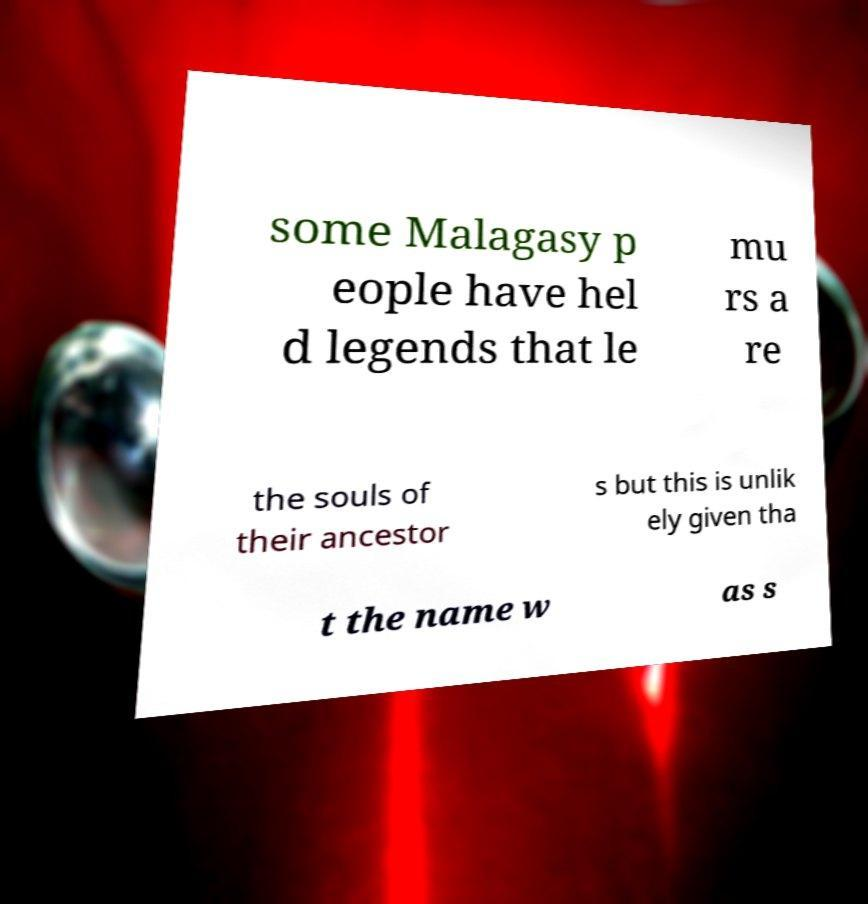Could you assist in decoding the text presented in this image and type it out clearly? some Malagasy p eople have hel d legends that le mu rs a re the souls of their ancestor s but this is unlik ely given tha t the name w as s 